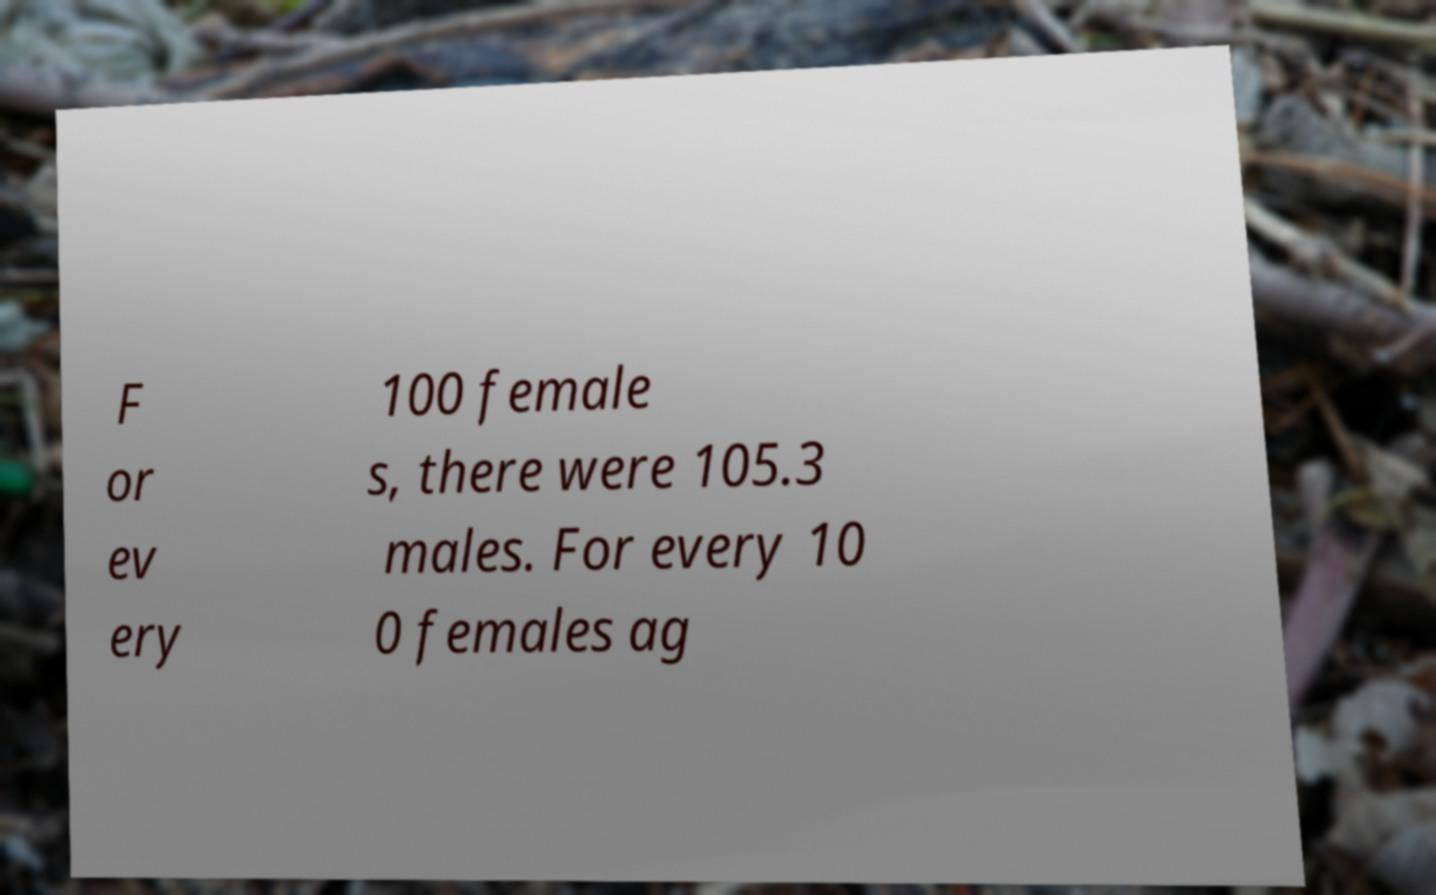Please read and relay the text visible in this image. What does it say? F or ev ery 100 female s, there were 105.3 males. For every 10 0 females ag 